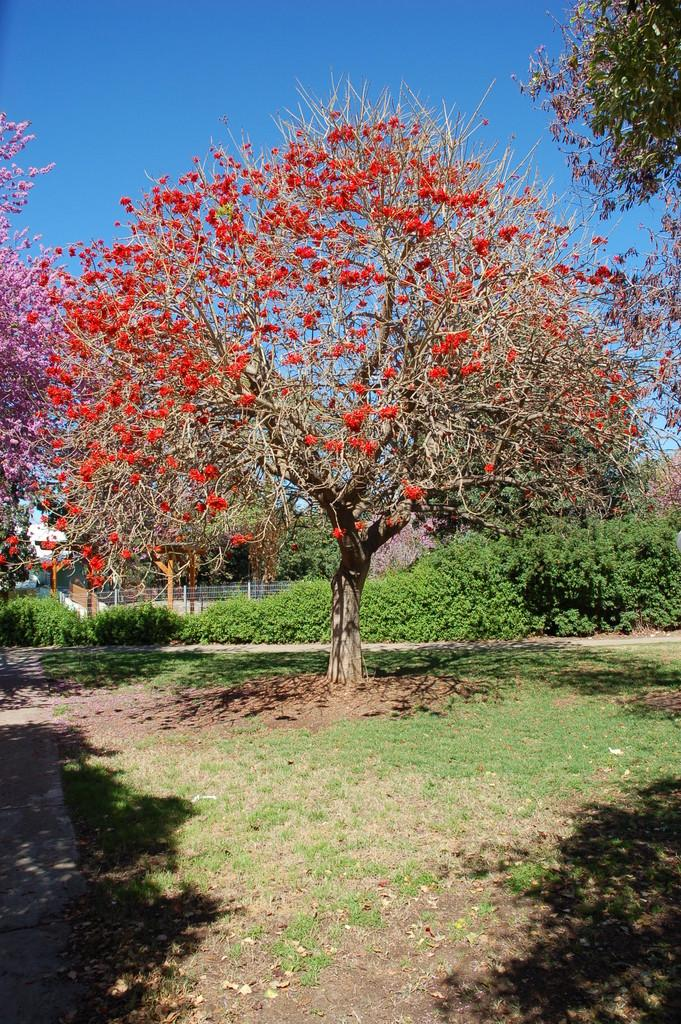What type of vegetation can be seen in the image? There are green trees in the image. What colors are the flowers in the image? The flowers in the image are in red and pink colors. What is the material used for the fencing in the image? The fencing visible in the image is made of a material that is not specified. What type of ground cover is present in the image? There is green grass in the image. What color is the sky in the image? The sky is blue in the image. Can you hear a cough in the image? There is no sound present in the image, so it is not possible to hear a cough. What type of friction can be observed between the flowers and the trees in the image? There is no friction between the flowers and the trees in the image, as they are separate elements in the scene. Is there a circle visible in the image? There is no circle present in the image. 